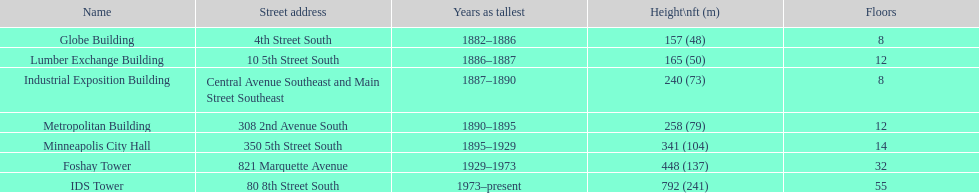How long did the lumber exchange building stand as the tallest building? 1 year. 